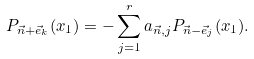<formula> <loc_0><loc_0><loc_500><loc_500>P _ { \vec { n } + \vec { e } _ { k } } ( x _ { 1 } ) = - \sum _ { j = 1 } ^ { r } a _ { \vec { n } , j } P _ { \vec { n } - \vec { e } _ { j } } ( x _ { 1 } ) .</formula> 